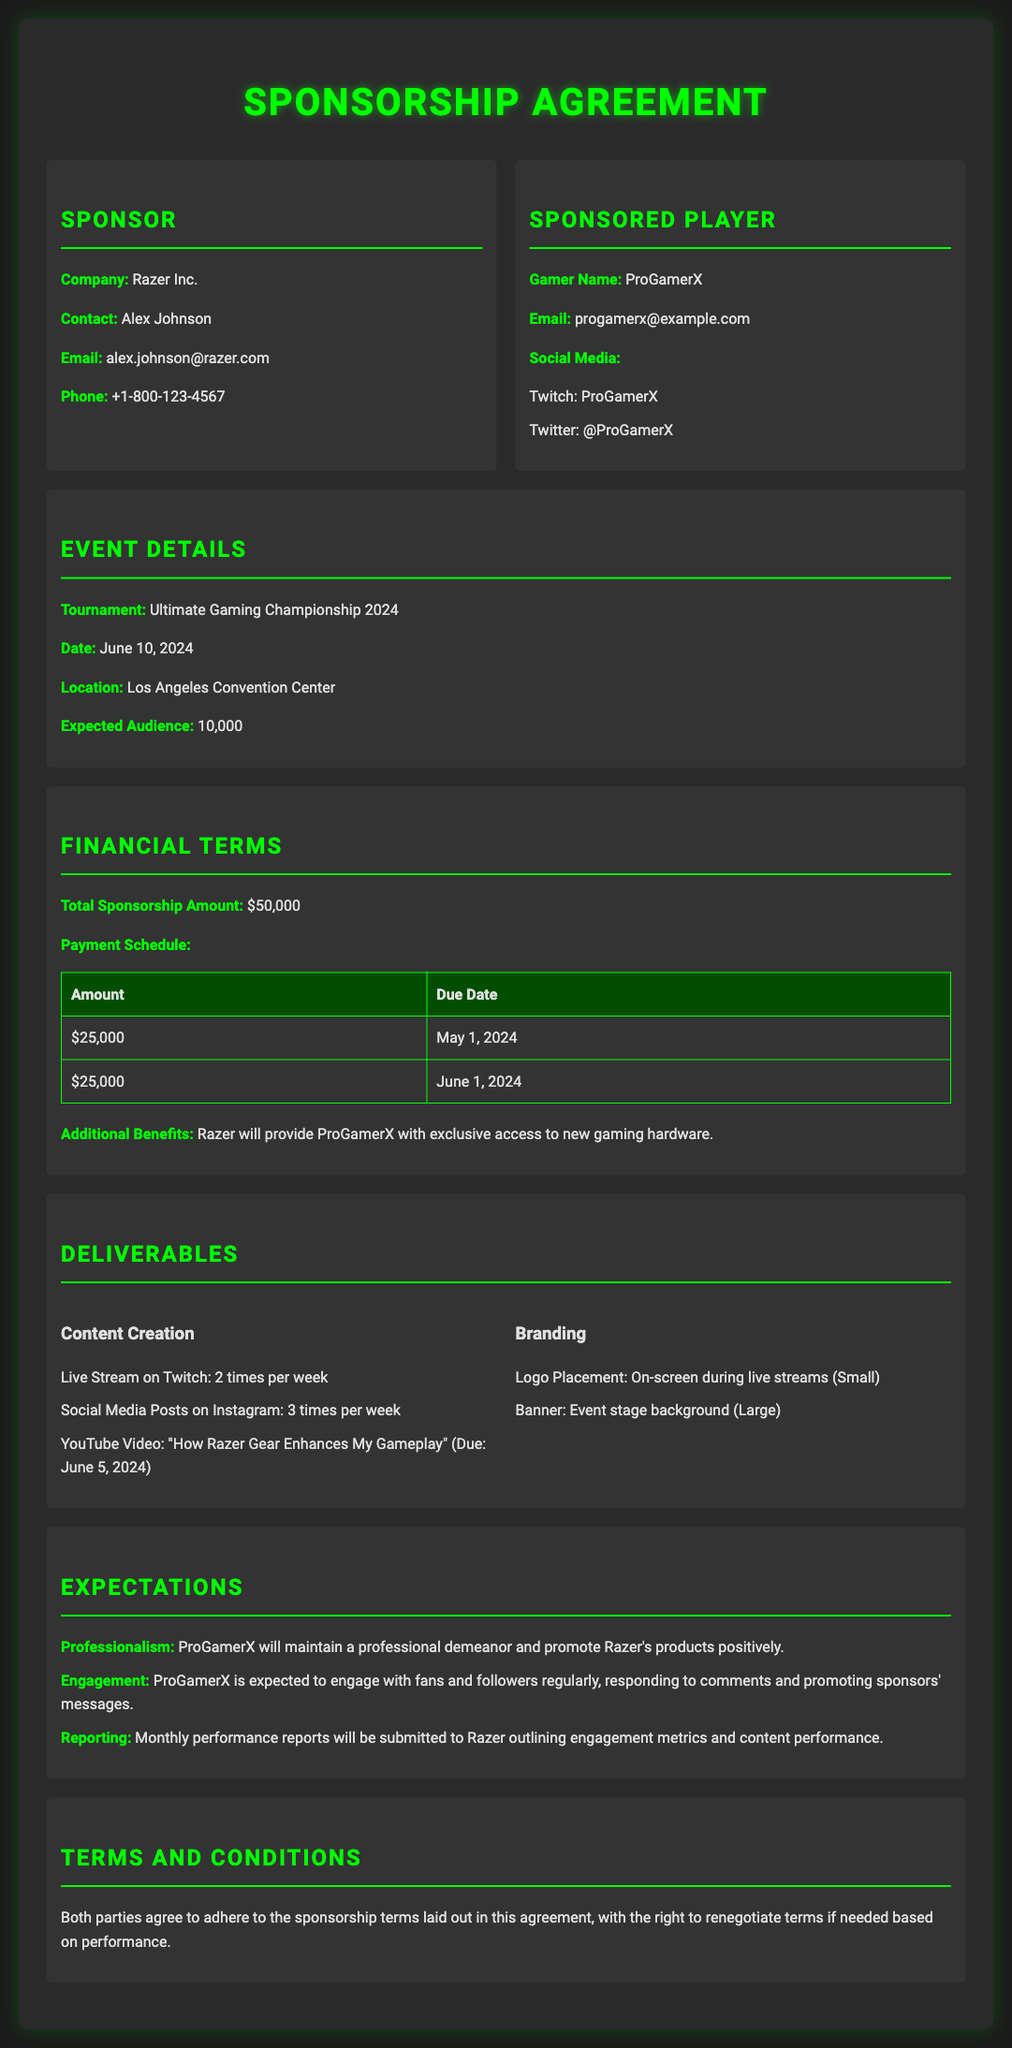What is the total sponsorship amount? The total sponsorship amount is specified in the financial terms section of the document as $50,000.
Answer: $50,000 What is the date of the tournament? The tournament date is mentioned under event details, which is June 10, 2024.
Answer: June 10, 2024 Who is the contact person at Razer Inc.? The contact person at Razer Inc. is listed as Alex Johnson in the sponsor section of the document.
Answer: Alex Johnson How many times per week is ProGamerX expected to live stream on Twitch? The deliverables section specifies that ProGamerX should live stream on Twitch two times per week.
Answer: 2 times per week What is the due date for the second payment? The payment schedule outlines that the second payment of $25,000 is due on June 1, 2024.
Answer: June 1, 2024 What does ProGamerX need to produce for YouTube? Under content creation, it is required to produce a YouTube video titled "How Razer Gear Enhances My Gameplay" due on June 5, 2024.
Answer: "How Razer Gear Enhances My Gameplay" What is one of the engagement expectations for ProGamerX? The expectations section states that ProGamerX must engage with fans and followers regularly and respond to comments.
Answer: Engage with fans What is the location of the tournament? The document lists the tournament location as Los Angeles Convention Center in the event details.
Answer: Los Angeles Convention Center What type of logo placement is specified during the live streams? The branding section specifies a small logo placement on-screen during live streams.
Answer: Small 